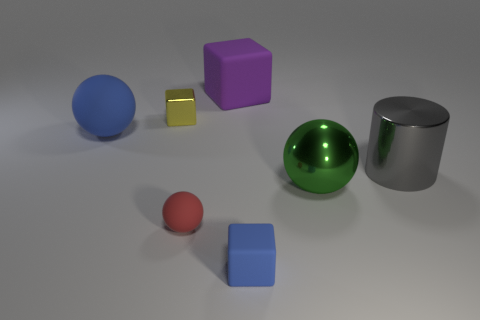Is there any other thing that is the same color as the metallic block?
Make the answer very short. No. What is the color of the shiny object that is behind the rubber ball on the left side of the tiny yellow shiny block?
Provide a succinct answer. Yellow. Are there fewer green things that are in front of the red sphere than metallic cylinders behind the big cube?
Keep it short and to the point. No. There is a thing that is the same color as the tiny matte cube; what is its material?
Your answer should be compact. Rubber. What number of objects are either rubber objects that are left of the tiny red thing or big cyan rubber balls?
Provide a succinct answer. 1. Do the ball that is left of the red ball and the tiny blue rubber thing have the same size?
Your response must be concise. No. Are there fewer matte blocks that are behind the small rubber block than green metallic balls?
Your response must be concise. No. There is a purple thing that is the same size as the blue matte ball; what material is it?
Keep it short and to the point. Rubber. How many big objects are either gray shiny cylinders or blocks?
Your answer should be compact. 2. How many things are either blue things behind the green ball or blue spheres behind the red matte thing?
Your response must be concise. 1. 